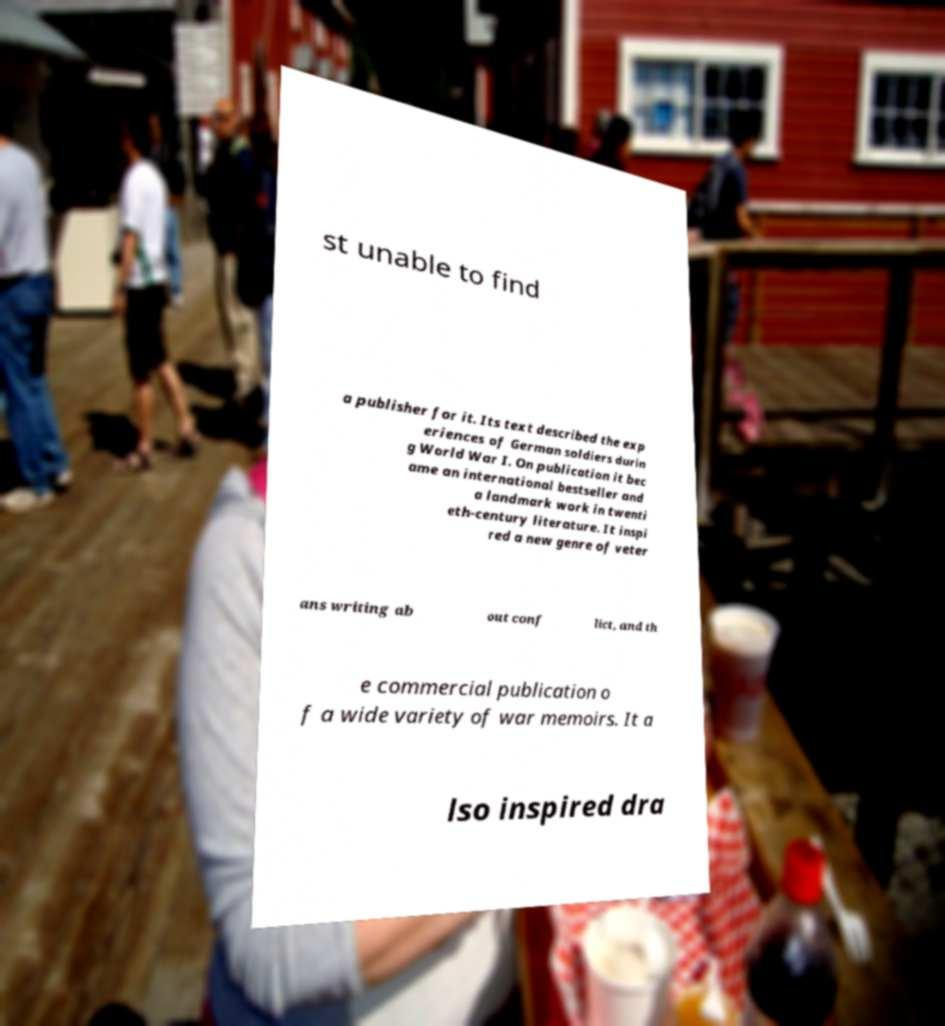Can you accurately transcribe the text from the provided image for me? st unable to find a publisher for it. Its text described the exp eriences of German soldiers durin g World War I. On publication it bec ame an international bestseller and a landmark work in twenti eth-century literature. It inspi red a new genre of veter ans writing ab out conf lict, and th e commercial publication o f a wide variety of war memoirs. It a lso inspired dra 